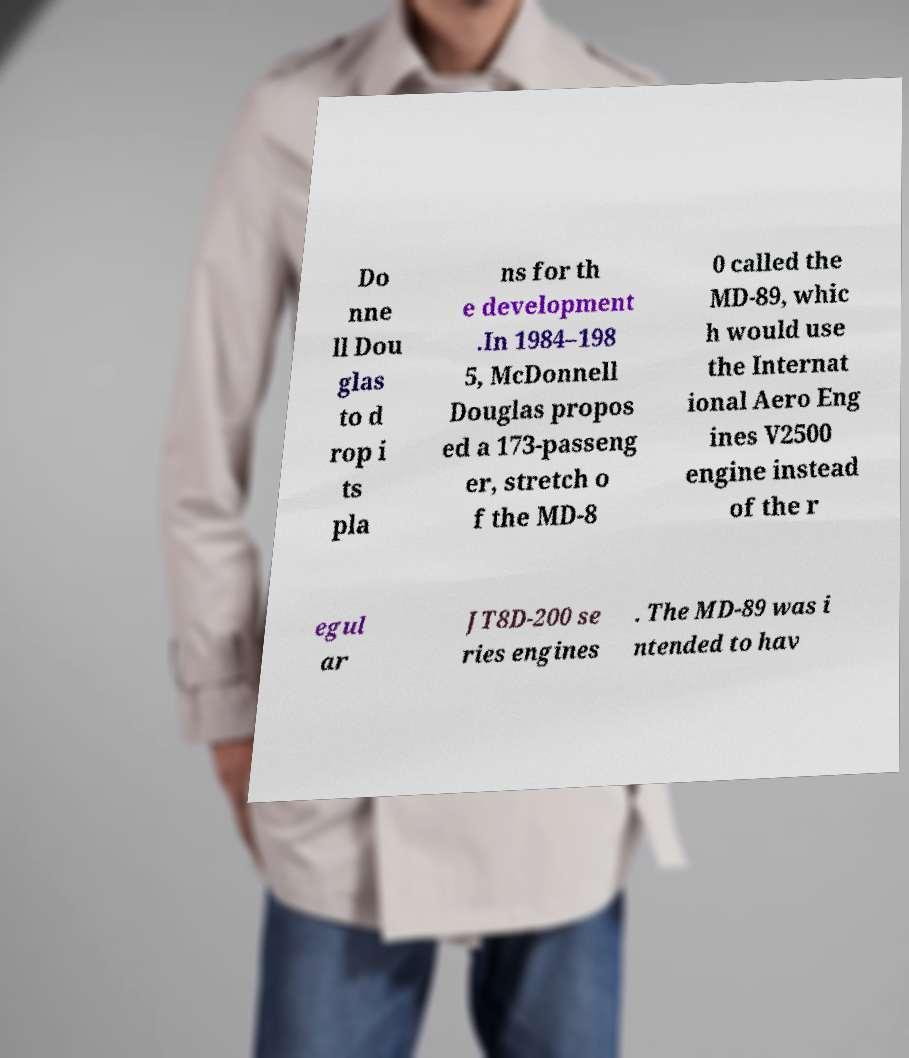What messages or text are displayed in this image? I need them in a readable, typed format. Do nne ll Dou glas to d rop i ts pla ns for th e development .In 1984–198 5, McDonnell Douglas propos ed a 173-passeng er, stretch o f the MD-8 0 called the MD-89, whic h would use the Internat ional Aero Eng ines V2500 engine instead of the r egul ar JT8D-200 se ries engines . The MD-89 was i ntended to hav 